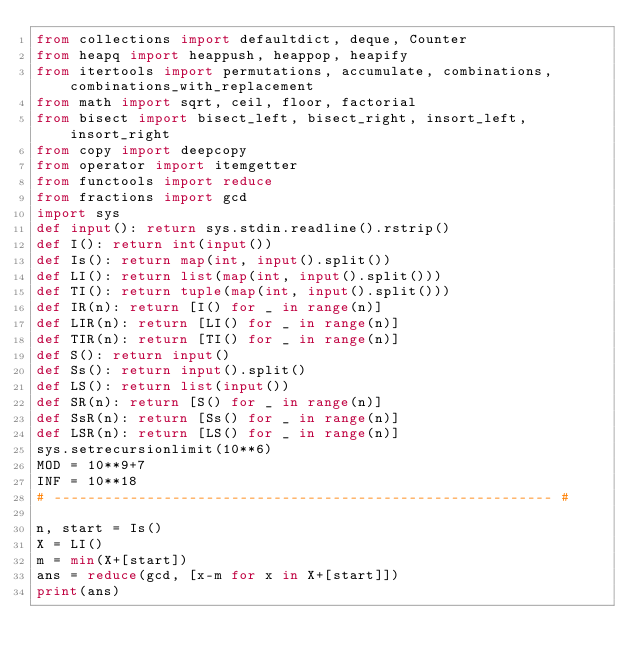Convert code to text. <code><loc_0><loc_0><loc_500><loc_500><_Python_>from collections import defaultdict, deque, Counter
from heapq import heappush, heappop, heapify
from itertools import permutations, accumulate, combinations, combinations_with_replacement
from math import sqrt, ceil, floor, factorial
from bisect import bisect_left, bisect_right, insort_left, insort_right
from copy import deepcopy
from operator import itemgetter
from functools import reduce
from fractions import gcd
import sys
def input(): return sys.stdin.readline().rstrip()
def I(): return int(input())
def Is(): return map(int, input().split())
def LI(): return list(map(int, input().split()))
def TI(): return tuple(map(int, input().split()))
def IR(n): return [I() for _ in range(n)]
def LIR(n): return [LI() for _ in range(n)]
def TIR(n): return [TI() for _ in range(n)]
def S(): return input()
def Ss(): return input().split()
def LS(): return list(input())
def SR(n): return [S() for _ in range(n)]
def SsR(n): return [Ss() for _ in range(n)]
def LSR(n): return [LS() for _ in range(n)]
sys.setrecursionlimit(10**6)
MOD = 10**9+7
INF = 10**18
# ----------------------------------------------------------- #

n, start = Is()
X = LI()
m = min(X+[start])
ans = reduce(gcd, [x-m for x in X+[start]])
print(ans)
</code> 